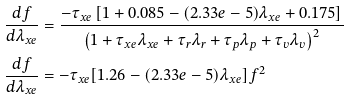Convert formula to latex. <formula><loc_0><loc_0><loc_500><loc_500>\frac { d f } { d \lambda _ { x e } } & = \frac { - \tau _ { x e } \left [ 1 + 0 . 0 8 5 - ( 2 . 3 3 e - 5 ) \lambda _ { x e } + 0 . 1 7 5 \right ] } { \left ( 1 + \tau _ { x e } \lambda _ { x e } + \tau _ { r } \lambda _ { r } + \tau _ { p } \lambda _ { p } + \tau _ { v } \lambda _ { v } \right ) ^ { 2 } } \\ \frac { d f } { d \lambda _ { x e } } & = - \tau _ { x e } [ 1 . 2 6 - ( 2 . 3 3 e - 5 ) \lambda _ { x e } ] { f ^ { 2 } }</formula> 